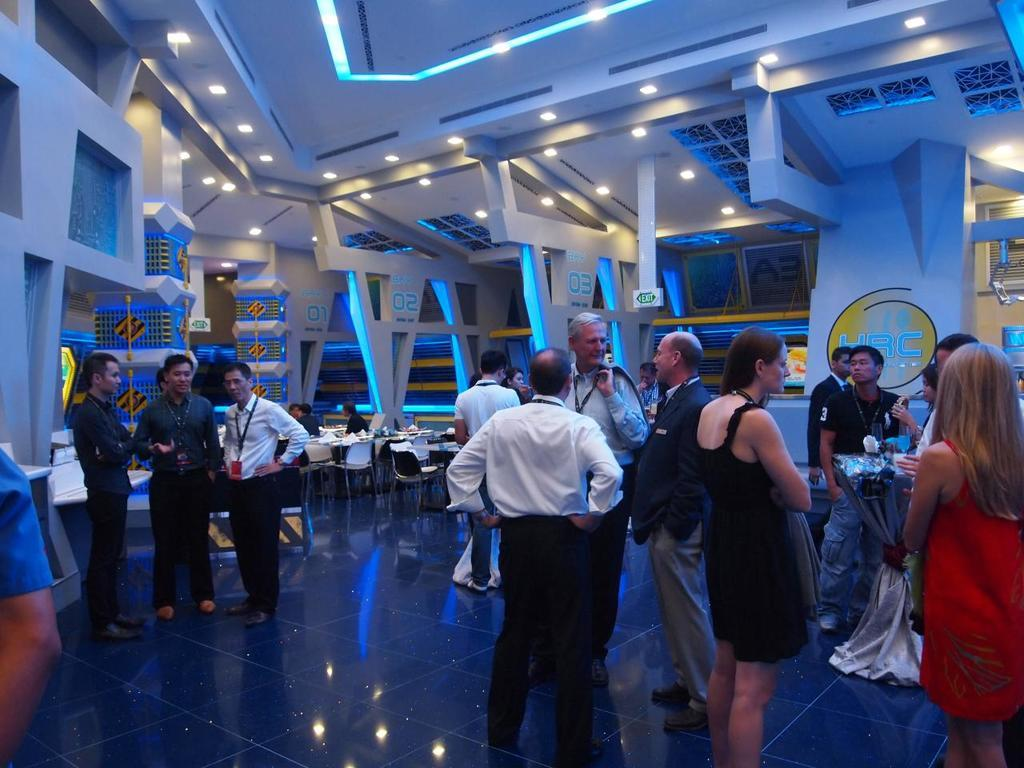What are the people in the image doing? The people in the image are standing and talking. Are there any people sitting in the image? Yes, there are people seated on chairs in the image. What are the seated people positioned near? The seated people are positioned near tables in the image. What type of wood is the tramp made of in the image? There is no tramp present in the image, so it is not possible to determine what type of wood it might be made of. 